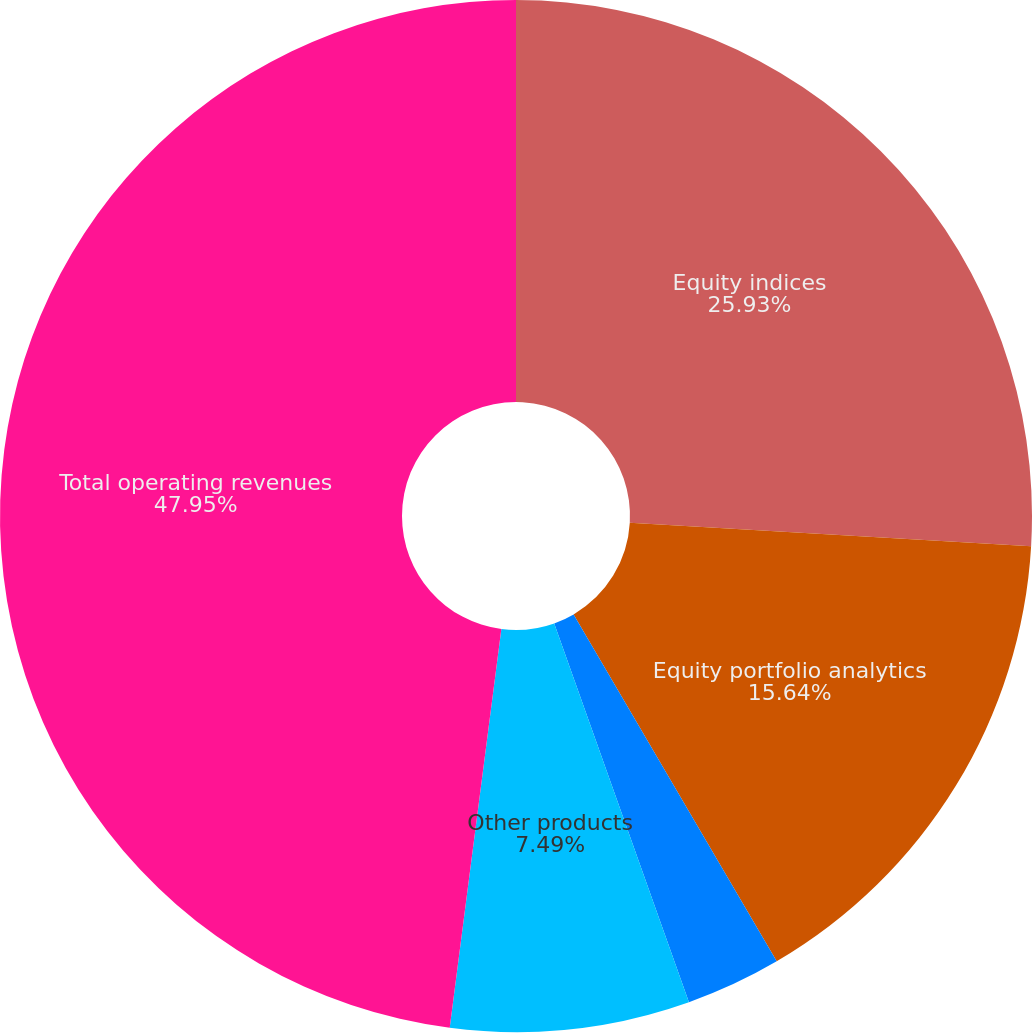Convert chart to OTSL. <chart><loc_0><loc_0><loc_500><loc_500><pie_chart><fcel>Equity indices<fcel>Equity portfolio analytics<fcel>Multi-asset class analytics<fcel>Other products<fcel>Total operating revenues<nl><fcel>25.93%<fcel>15.64%<fcel>2.99%<fcel>7.49%<fcel>47.95%<nl></chart> 